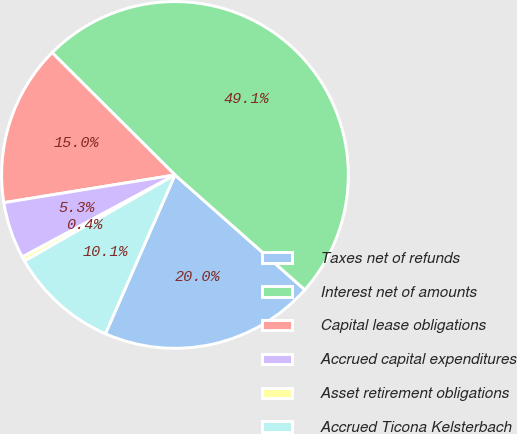Convert chart. <chart><loc_0><loc_0><loc_500><loc_500><pie_chart><fcel>Taxes net of refunds<fcel>Interest net of amounts<fcel>Capital lease obligations<fcel>Accrued capital expenditures<fcel>Asset retirement obligations<fcel>Accrued Ticona Kelsterbach<nl><fcel>20.05%<fcel>49.06%<fcel>15.02%<fcel>5.29%<fcel>0.43%<fcel>10.15%<nl></chart> 